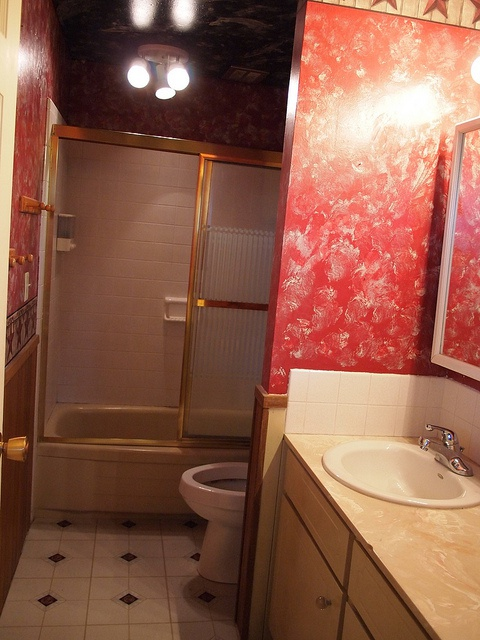Describe the objects in this image and their specific colors. I can see sink in tan and gray tones and toilet in tan, maroon, brown, black, and gray tones in this image. 